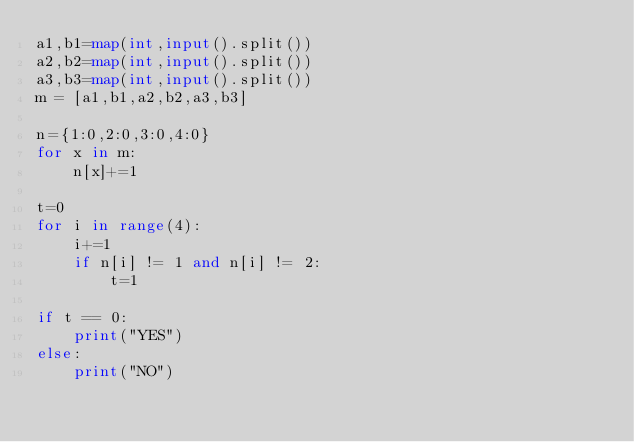Convert code to text. <code><loc_0><loc_0><loc_500><loc_500><_Python_>a1,b1=map(int,input().split())
a2,b2=map(int,input().split())
a3,b3=map(int,input().split())
m = [a1,b1,a2,b2,a3,b3]

n={1:0,2:0,3:0,4:0}
for x in m:
    n[x]+=1
    
t=0
for i in range(4):
    i+=1
    if n[i] != 1 and n[i] != 2:
        t=1
        
if t == 0:
    print("YES")
else:
    print("NO")
</code> 